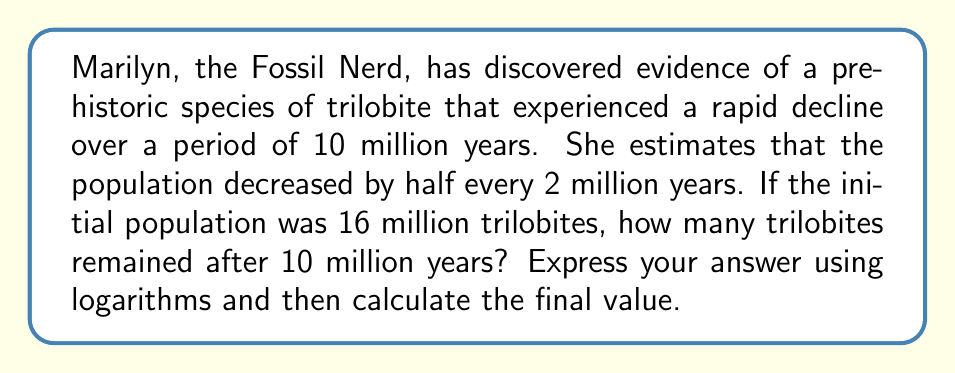Can you answer this question? Let's approach this step-by-step:

1) First, we need to identify the exponential decay formula:
   $$ N(t) = N_0 \cdot (1/2)^{t/h} $$
   where $N(t)$ is the population at time $t$, $N_0$ is the initial population, and $h$ is the half-life.

2) We know:
   - $N_0 = 16$ million
   - $h = 2$ million years
   - $t = 10$ million years

3) Plugging these values into our formula:
   $$ N(10) = 16 \cdot (1/2)^{10/2} = 16 \cdot (1/2)^5 $$

4) To solve this using logarithms, let's apply $\log_2$ to both sides:
   $$ \log_2(N(10)) = \log_2(16 \cdot (1/2)^5) $$

5) Using the logarithm product rule:
   $$ \log_2(N(10)) = \log_2(16) + \log_2((1/2)^5) $$

6) Simplify:
   $$ \log_2(N(10)) = 4 + 5 \cdot \log_2(1/2) = 4 + 5 \cdot (-1) = 4 - 5 = -1 $$

7) Therefore:
   $$ N(10) = 2^{-1} = 1/2 $$

8) The final population is 0.5 million or 500,000 trilobites.
Answer: The number of trilobites after 10 million years can be expressed as $2^{-1}$ million, which equals 0.5 million or 500,000 trilobites. 